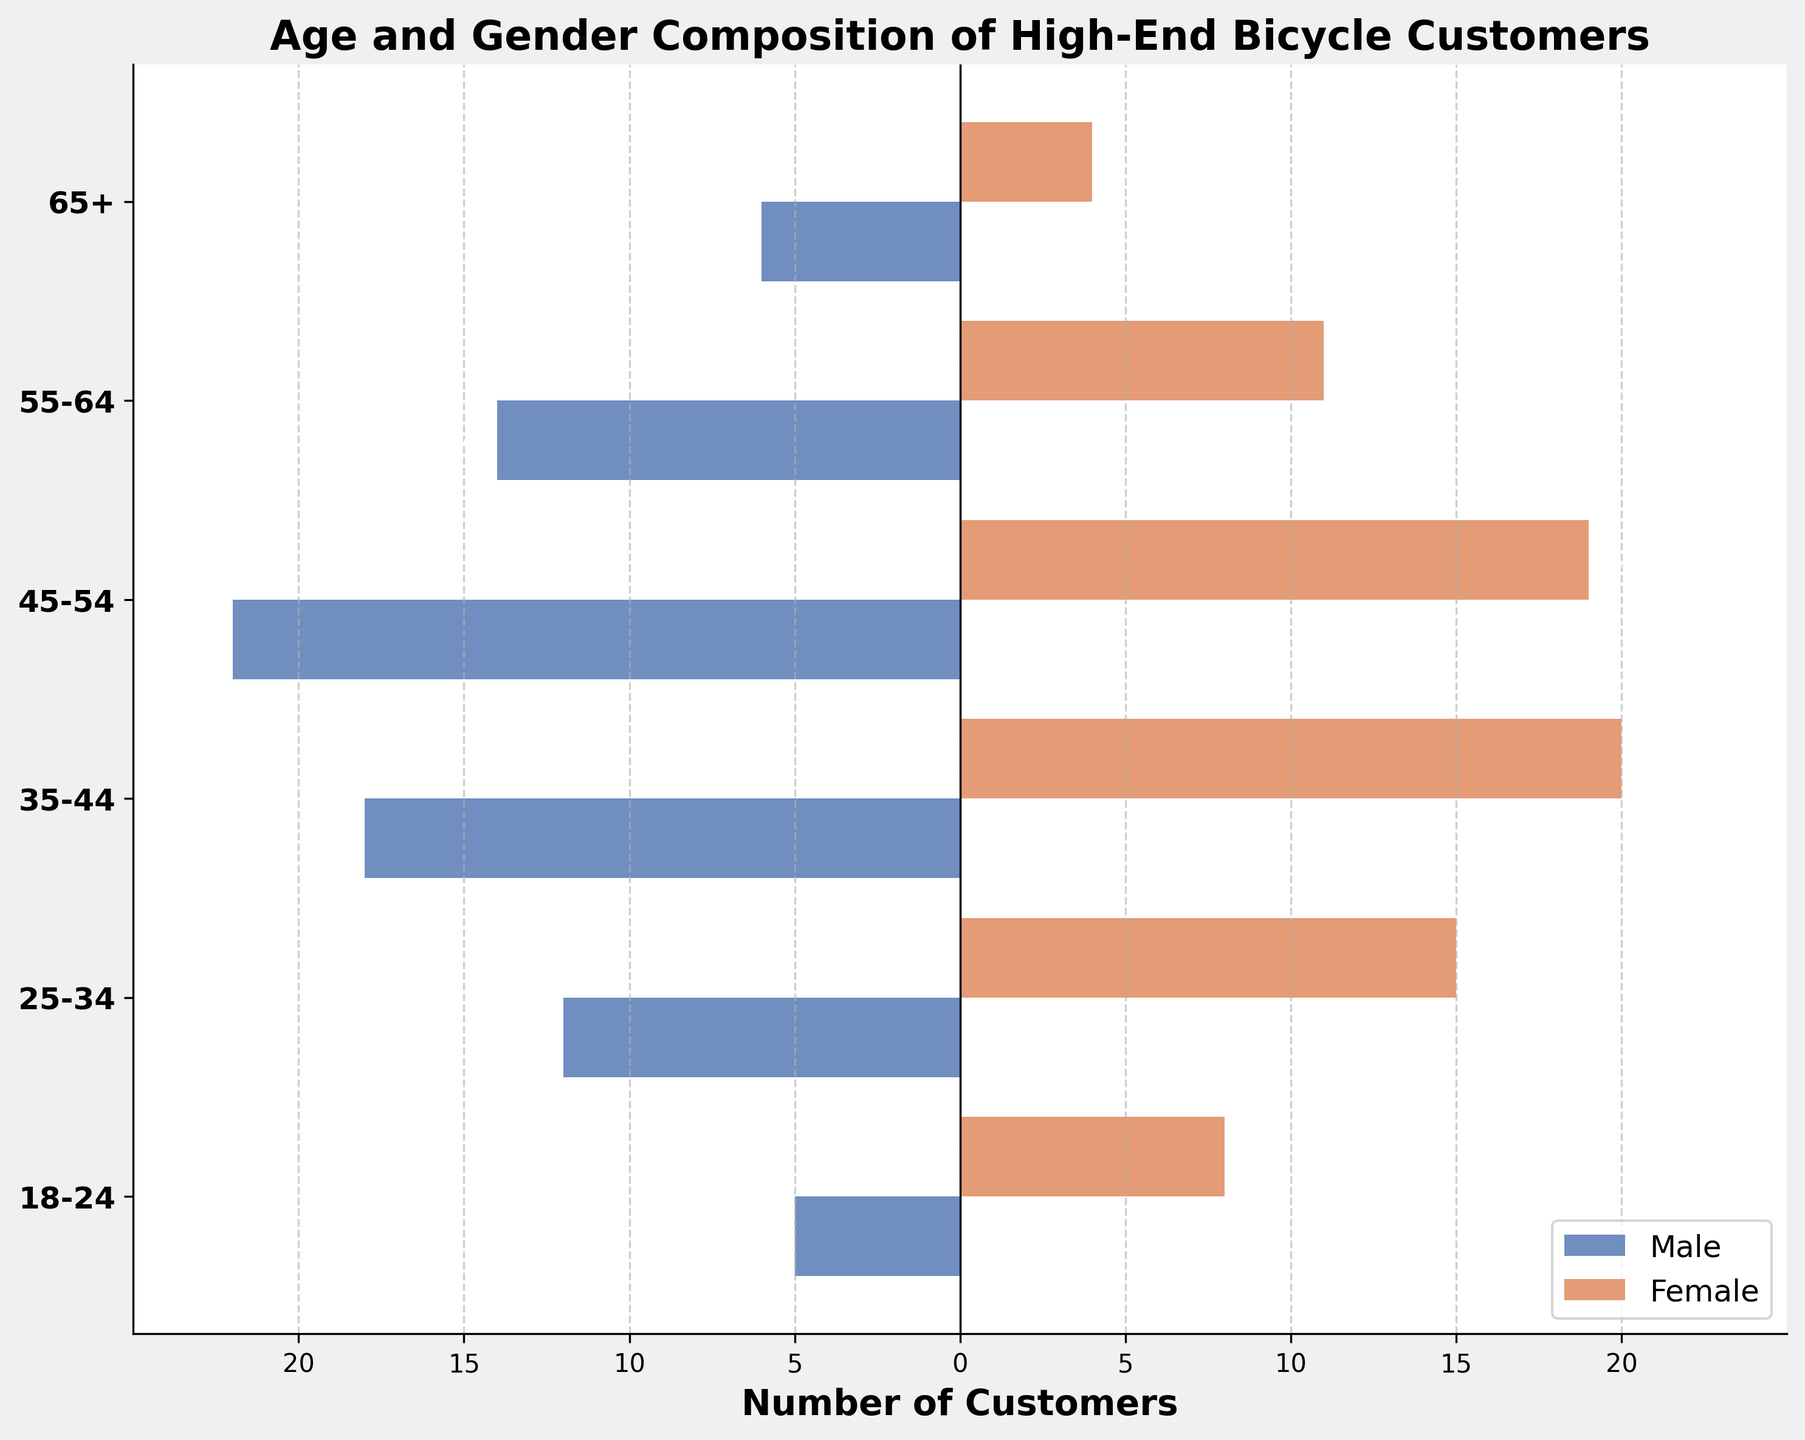How many male customers are there in the 35-44 age group? Look at the bar corresponding to the 35-44 age group on the male side and read the value.
Answer: 18 Which age group has the highest number of female customers? Compare the length of the bars on the female side for all age groups and find the one with the longest bar.
Answer: 35-44 What is the total number of customers aged 45-54? Add the number of male (22) and female (19) customers in the 45-54 age group.
Answer: 41 How does the number of male customers aged 55-64 compare to female customers in the same age group? Compare the lengths of the male and female bars for the 55-64 age group. The male bar is longer, indicating more male customers.
Answer: More males What is the gender ratio (M:F) for customers aged 25-34? Divide the number of male customers (12) by the number of female customers (15) for the 25-34 age group to find the ratio.
Answer: 12:15 What is the sum of male customers in the 18-24 and 65+ age groups? Add the number of male customers in the 18-24 (5) and 65+ (6) age groups.
Answer: 11 Which gender has more customers overall? Sum the values of male and female customers across all age groups separately and compare the totals.
Answer: Female Calculate the average number of female customers per age group. Sum the number of female customers (8 + 15 + 20 + 19 + 11 + 4 = 77) and divide by the number of age groups (6).
Answer: 12.83 Which age group shows the smallest discrepancy between male and female customers? Evaluate the absolute difference between male and female customers in each age group and identify the smallest value.
Answer: 65+ How many female customers are there in the 25-54 age range? Add the number of female customers in the 25-34 (15), 35-44 (20), and 45-54 (19) age groups.
Answer: 54 